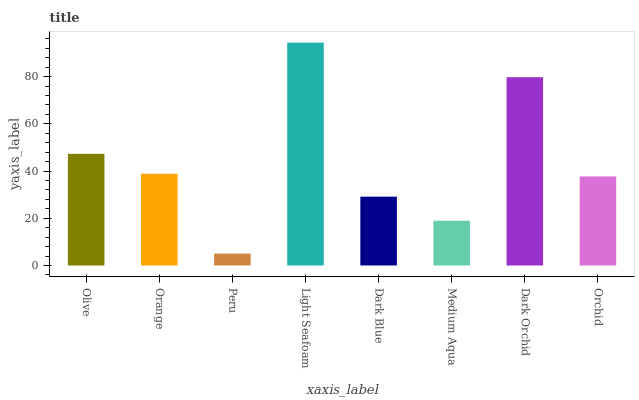Is Peru the minimum?
Answer yes or no. Yes. Is Light Seafoam the maximum?
Answer yes or no. Yes. Is Orange the minimum?
Answer yes or no. No. Is Orange the maximum?
Answer yes or no. No. Is Olive greater than Orange?
Answer yes or no. Yes. Is Orange less than Olive?
Answer yes or no. Yes. Is Orange greater than Olive?
Answer yes or no. No. Is Olive less than Orange?
Answer yes or no. No. Is Orange the high median?
Answer yes or no. Yes. Is Orchid the low median?
Answer yes or no. Yes. Is Peru the high median?
Answer yes or no. No. Is Peru the low median?
Answer yes or no. No. 